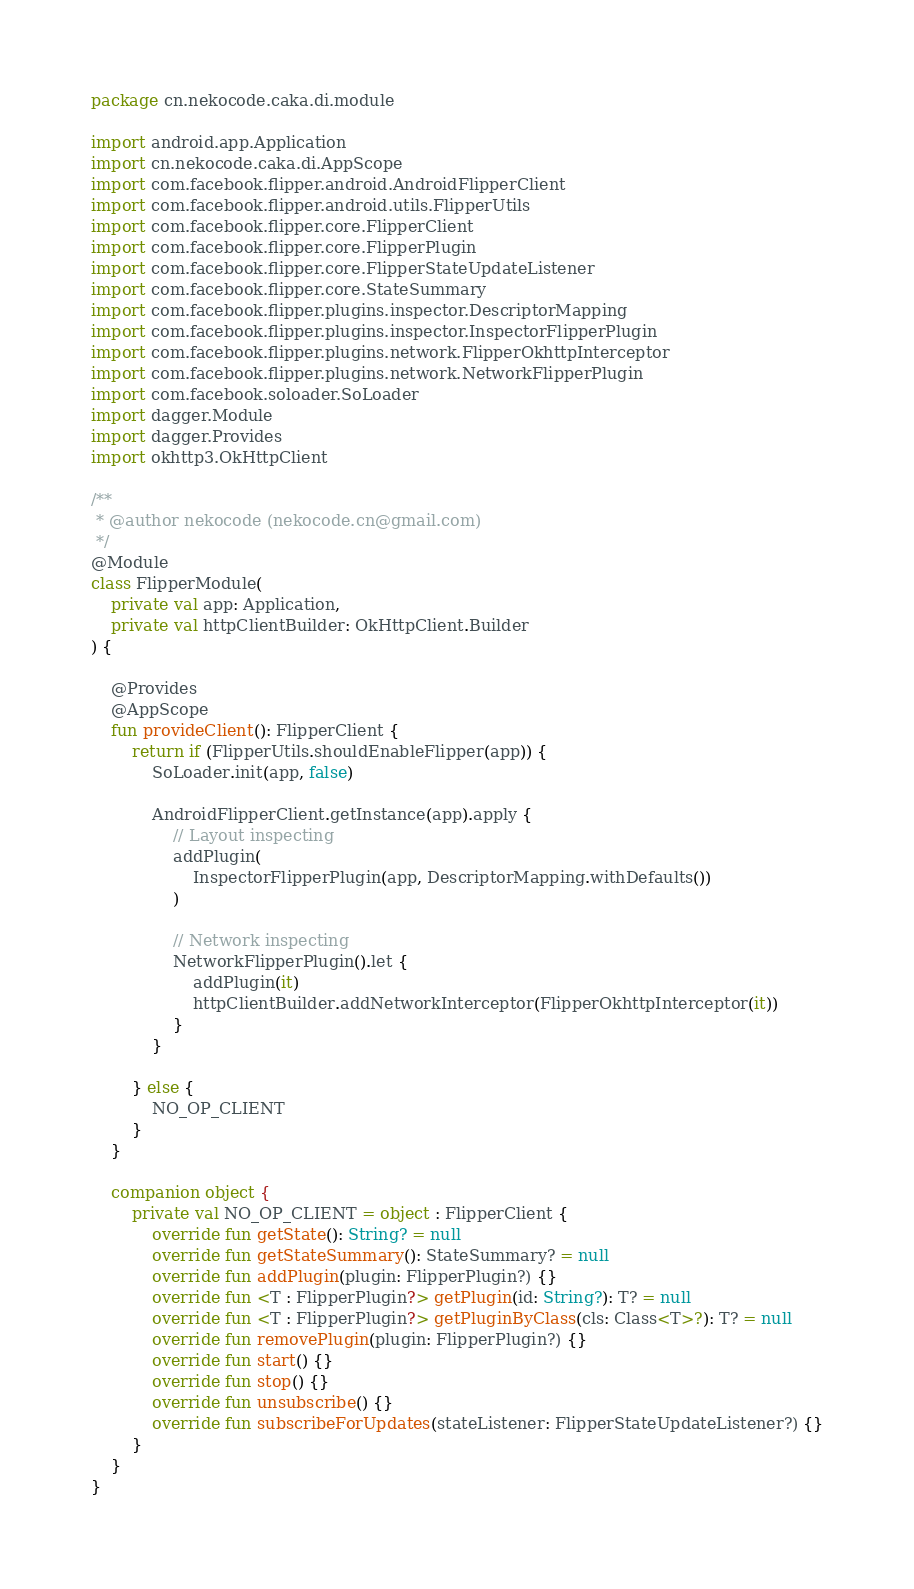Convert code to text. <code><loc_0><loc_0><loc_500><loc_500><_Kotlin_>package cn.nekocode.caka.di.module

import android.app.Application
import cn.nekocode.caka.di.AppScope
import com.facebook.flipper.android.AndroidFlipperClient
import com.facebook.flipper.android.utils.FlipperUtils
import com.facebook.flipper.core.FlipperClient
import com.facebook.flipper.core.FlipperPlugin
import com.facebook.flipper.core.FlipperStateUpdateListener
import com.facebook.flipper.core.StateSummary
import com.facebook.flipper.plugins.inspector.DescriptorMapping
import com.facebook.flipper.plugins.inspector.InspectorFlipperPlugin
import com.facebook.flipper.plugins.network.FlipperOkhttpInterceptor
import com.facebook.flipper.plugins.network.NetworkFlipperPlugin
import com.facebook.soloader.SoLoader
import dagger.Module
import dagger.Provides
import okhttp3.OkHttpClient

/**
 * @author nekocode (nekocode.cn@gmail.com)
 */
@Module
class FlipperModule(
    private val app: Application,
    private val httpClientBuilder: OkHttpClient.Builder
) {

    @Provides
    @AppScope
    fun provideClient(): FlipperClient {
        return if (FlipperUtils.shouldEnableFlipper(app)) {
            SoLoader.init(app, false)

            AndroidFlipperClient.getInstance(app).apply {
                // Layout inspecting
                addPlugin(
                    InspectorFlipperPlugin(app, DescriptorMapping.withDefaults())
                )

                // Network inspecting
                NetworkFlipperPlugin().let {
                    addPlugin(it)
                    httpClientBuilder.addNetworkInterceptor(FlipperOkhttpInterceptor(it))
                }
            }

        } else {
            NO_OP_CLIENT
        }
    }

    companion object {
        private val NO_OP_CLIENT = object : FlipperClient {
            override fun getState(): String? = null
            override fun getStateSummary(): StateSummary? = null
            override fun addPlugin(plugin: FlipperPlugin?) {}
            override fun <T : FlipperPlugin?> getPlugin(id: String?): T? = null
            override fun <T : FlipperPlugin?> getPluginByClass(cls: Class<T>?): T? = null
            override fun removePlugin(plugin: FlipperPlugin?) {}
            override fun start() {}
            override fun stop() {}
            override fun unsubscribe() {}
            override fun subscribeForUpdates(stateListener: FlipperStateUpdateListener?) {}
        }
    }
}</code> 